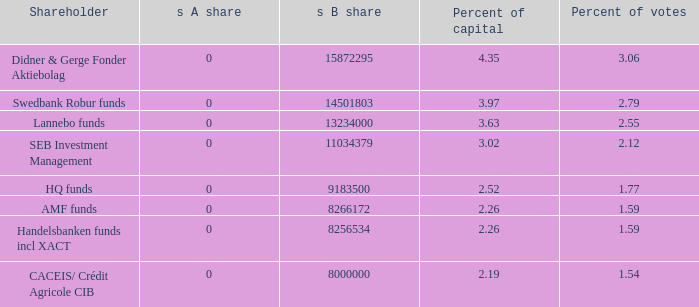55 percent of voting rights? Lannebo funds. 